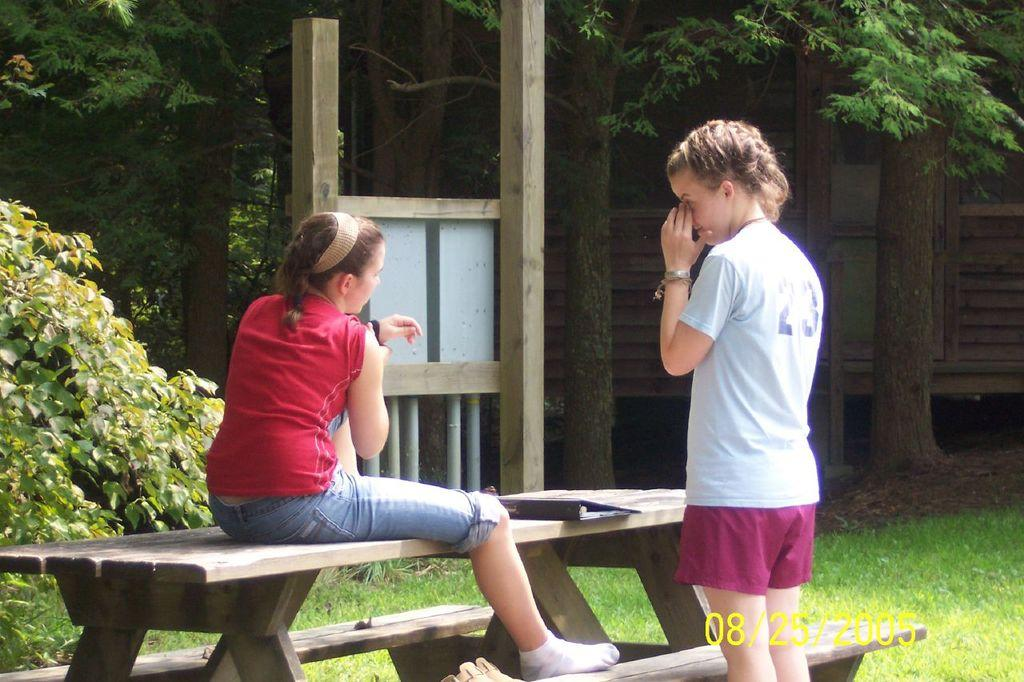Where was the image taken? The image was taken outside. How many girls are in the image? There are two girls in the image. What are the positions of the girls in the image? One girl is sitting on a bench, and another girl is sitting beside the bench. What can be seen in the background of the image? There is a tree and a plant in the background of the image. What is the profit margin of the plant in the image? There is no information about profit margins in the image, as it is a photograph of two girls sitting outside. 